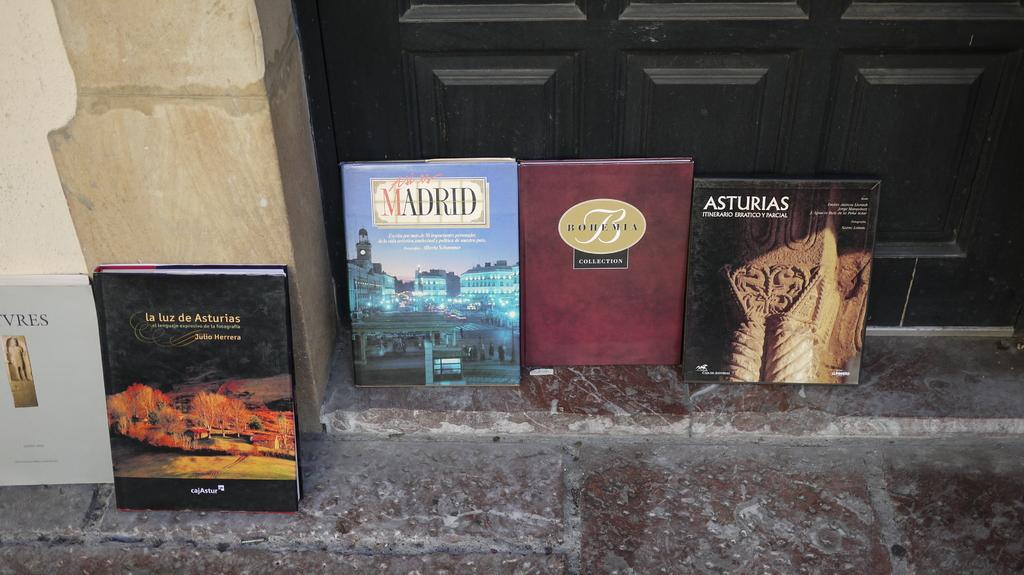What objects are in the front of the image? There are books in the front of the image. What can be seen in the background of the image? There is a black color object in the background of the image, which appears to be a door. Can you tell me how many fans are visible in the image? There are no fans present in the image. Is the mom visible in the image? There is no mention of a mom or any person in the image, so it cannot be determined if a mom is visible. 